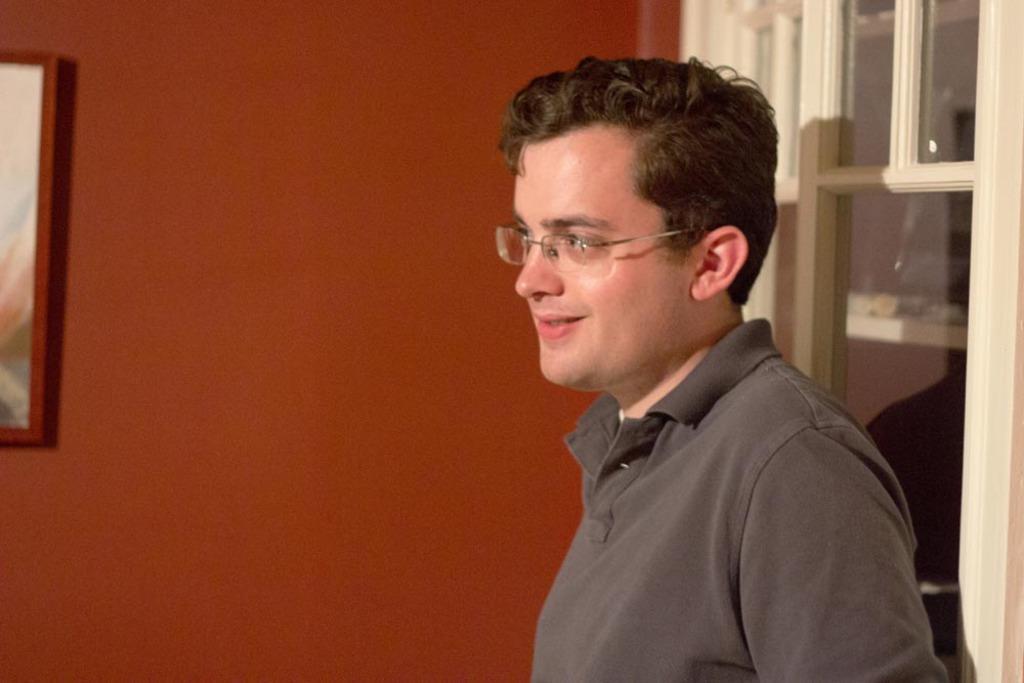In one or two sentences, can you explain what this image depicts? There is one man standing and wearing spectacles at the bottom of this image, and there is a red color wall in the background. There is one photo frame attached to it, and there is a window on the right side of this image. 